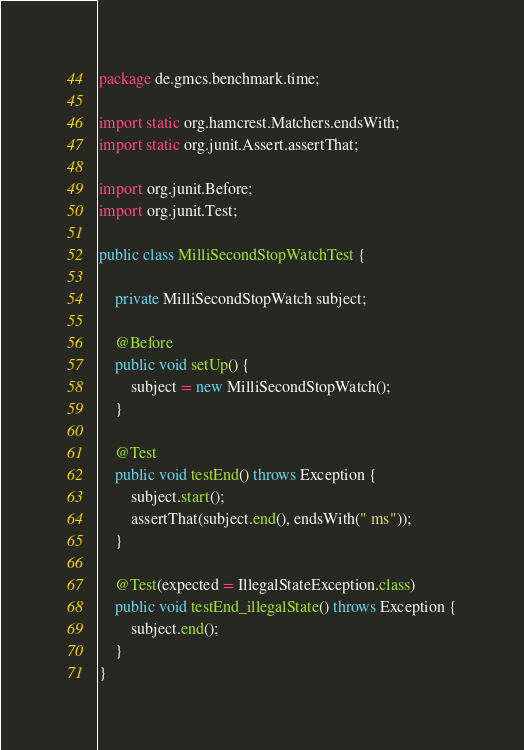Convert code to text. <code><loc_0><loc_0><loc_500><loc_500><_Java_>package de.gmcs.benchmark.time;

import static org.hamcrest.Matchers.endsWith;
import static org.junit.Assert.assertThat;

import org.junit.Before;
import org.junit.Test;

public class MilliSecondStopWatchTest {

    private MilliSecondStopWatch subject;

    @Before
    public void setUp() {
        subject = new MilliSecondStopWatch();
    }

    @Test
    public void testEnd() throws Exception {
        subject.start();
        assertThat(subject.end(), endsWith(" ms"));
    }

    @Test(expected = IllegalStateException.class)
    public void testEnd_illegalState() throws Exception {
        subject.end();
    }
}
</code> 